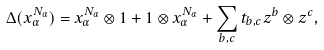<formula> <loc_0><loc_0><loc_500><loc_500>\Delta ( x _ { \alpha } ^ { N _ { \alpha } } ) = x _ { \alpha } ^ { N _ { \alpha } } \otimes 1 + 1 \otimes x _ { \alpha } ^ { N _ { \alpha } } + \sum _ { b , c } t _ { b , c } z ^ { b } \otimes z ^ { c } ,</formula> 